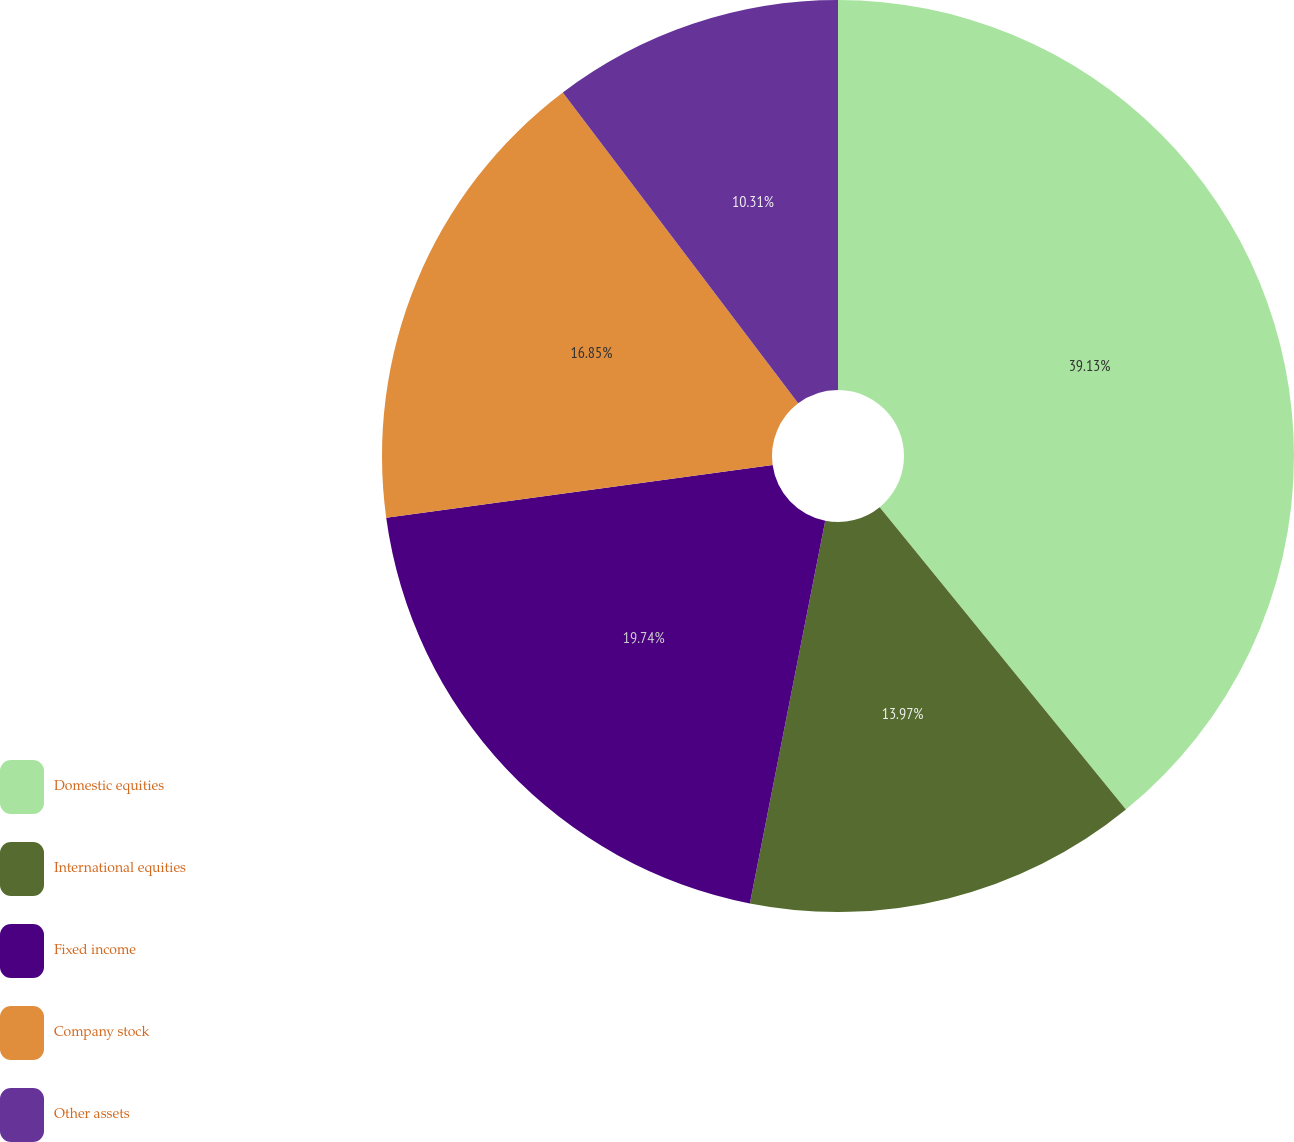Convert chart. <chart><loc_0><loc_0><loc_500><loc_500><pie_chart><fcel>Domestic equities<fcel>International equities<fcel>Fixed income<fcel>Company stock<fcel>Other assets<nl><fcel>39.12%<fcel>13.97%<fcel>19.74%<fcel>16.85%<fcel>10.31%<nl></chart> 